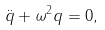Convert formula to latex. <formula><loc_0><loc_0><loc_500><loc_500>\ddot { q } + \omega ^ { 2 } q = 0 ,</formula> 